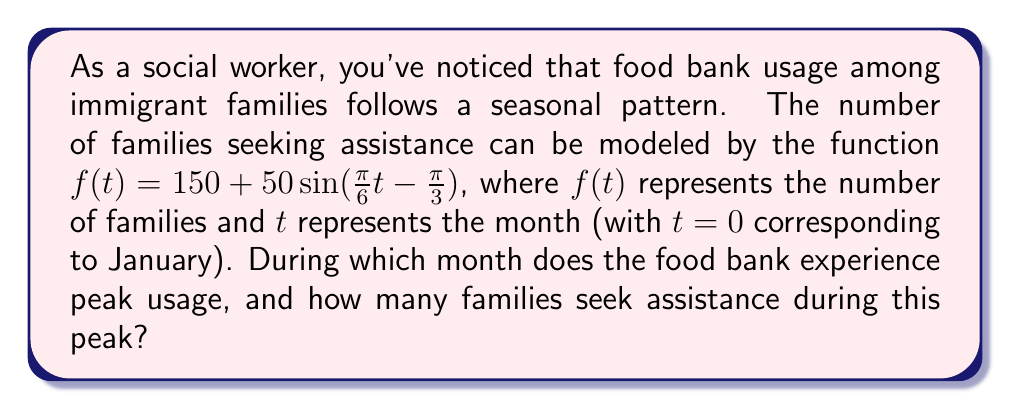Help me with this question. To solve this problem, we need to analyze the given sinusoidal function:

$f(t) = 150 + 50\sin(\frac{\pi}{6}t - \frac{\pi}{3})$

1. The midline of this function is at 150 families.
2. The amplitude is 50 families.
3. The period of the function is $\frac{2\pi}{\frac{\pi}{6}} = 12$ months, confirming an annual cycle.

To find the peak, we need to determine when $\sin(\frac{\pi}{6}t - \frac{\pi}{3})$ equals 1. This occurs when:

$$\frac{\pi}{6}t - \frac{\pi}{3} = \frac{\pi}{2} + 2\pi n, \text{ where } n \text{ is an integer}$$

Solving for $t$:

$$\frac{\pi}{6}t = \frac{\pi}{2} + \frac{\pi}{3} + 2\pi n$$
$$t = 5 + 12n$$

The smallest positive value of $t$ is 5, corresponding to May (since $t=0$ is January).

To calculate the peak number of families:

$$f(5) = 150 + 50\sin(\frac{\pi}{6}(5) - \frac{\pi}{3})$$
$$= 150 + 50\sin(\frac{5\pi}{6} - \frac{\pi}{3})$$
$$= 150 + 50\sin(\frac{\pi}{2})$$
$$= 150 + 50(1)$$
$$= 200$$

Therefore, the food bank experiences peak usage in May with 200 families seeking assistance.
Answer: The food bank experiences peak usage in May, with 200 families seeking assistance. 